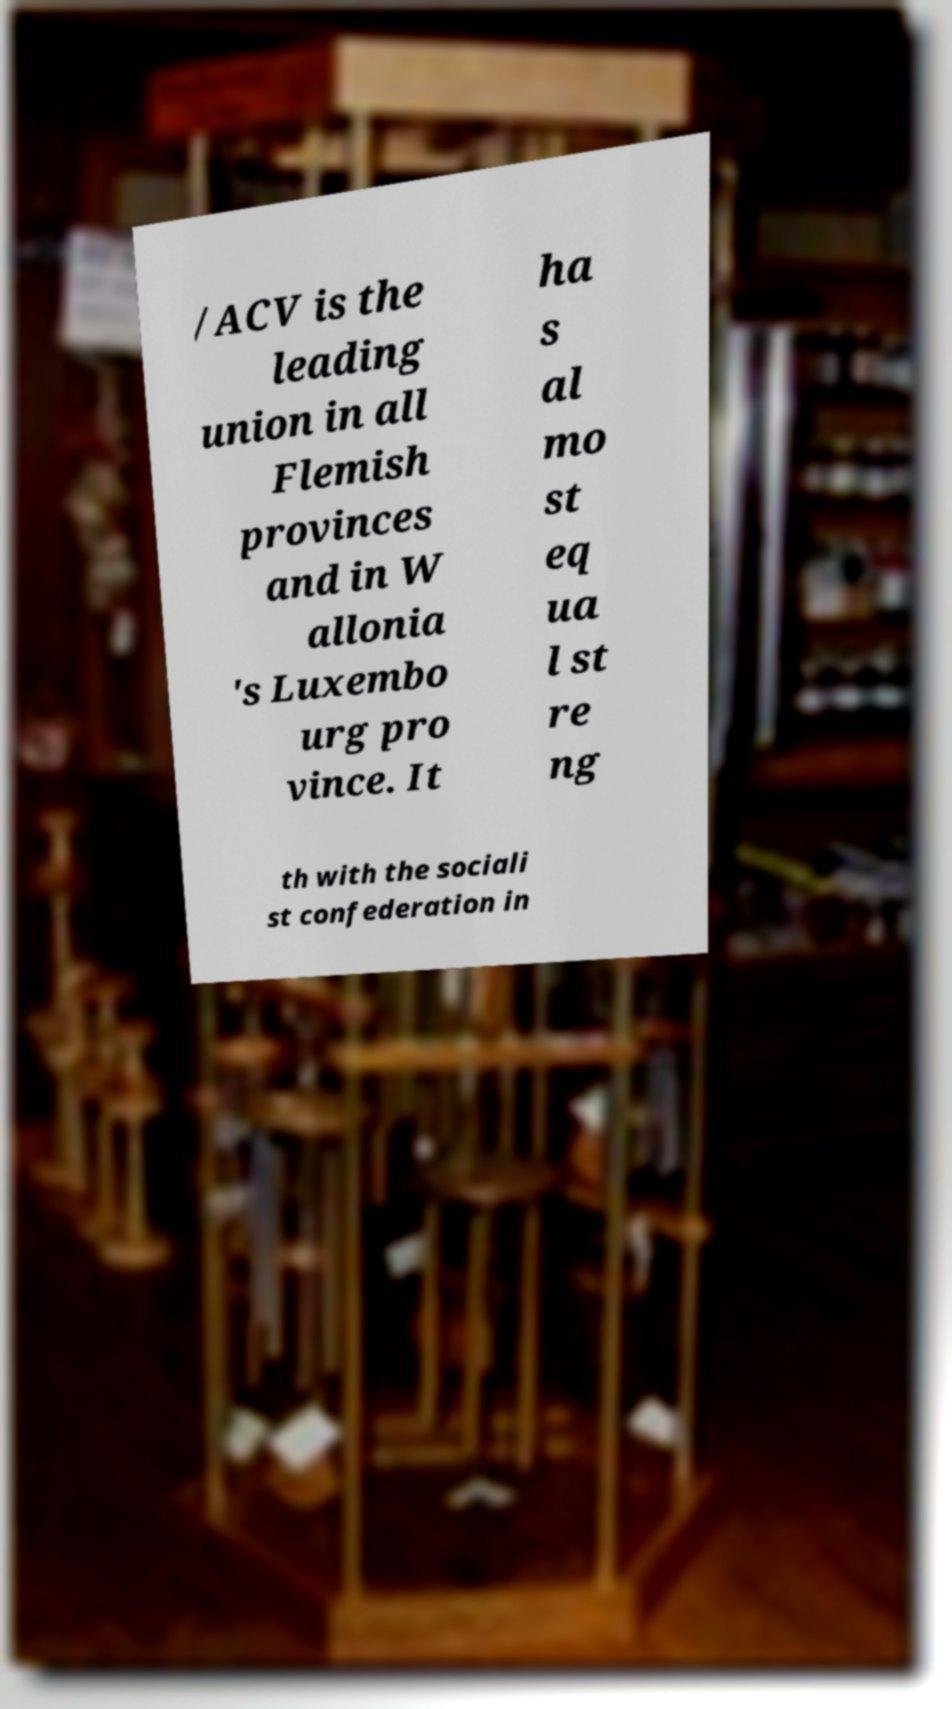What messages or text are displayed in this image? I need them in a readable, typed format. /ACV is the leading union in all Flemish provinces and in W allonia 's Luxembo urg pro vince. It ha s al mo st eq ua l st re ng th with the sociali st confederation in 